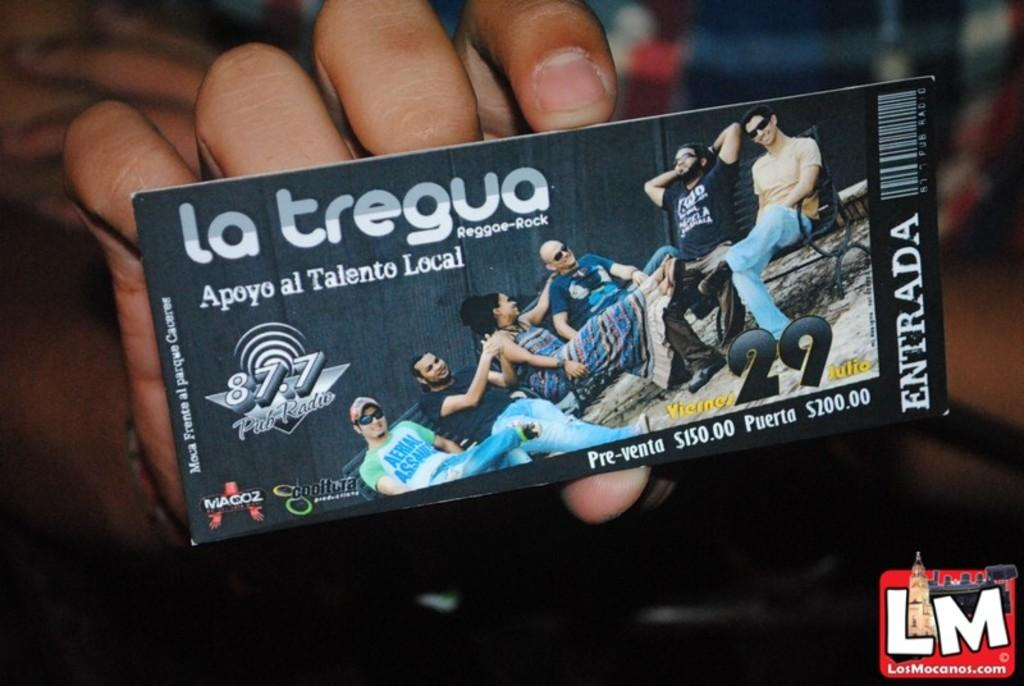What is the person in the image holding? The person is holding a ticket in the image. What can be found on the ticket? The ticket has text and numbers on it, and there are people visible on the ticket. What is the condition of the background in the image? The background of the image is blurry. What type of tax is being discussed on the shelf in the image? There is no shelf or tax mentioned in the image; it features a person holding a ticket with text and numbers on it. What song is being sung by the people on the ticket? There is no indication of a song being sung by the people on the ticket in the image. 